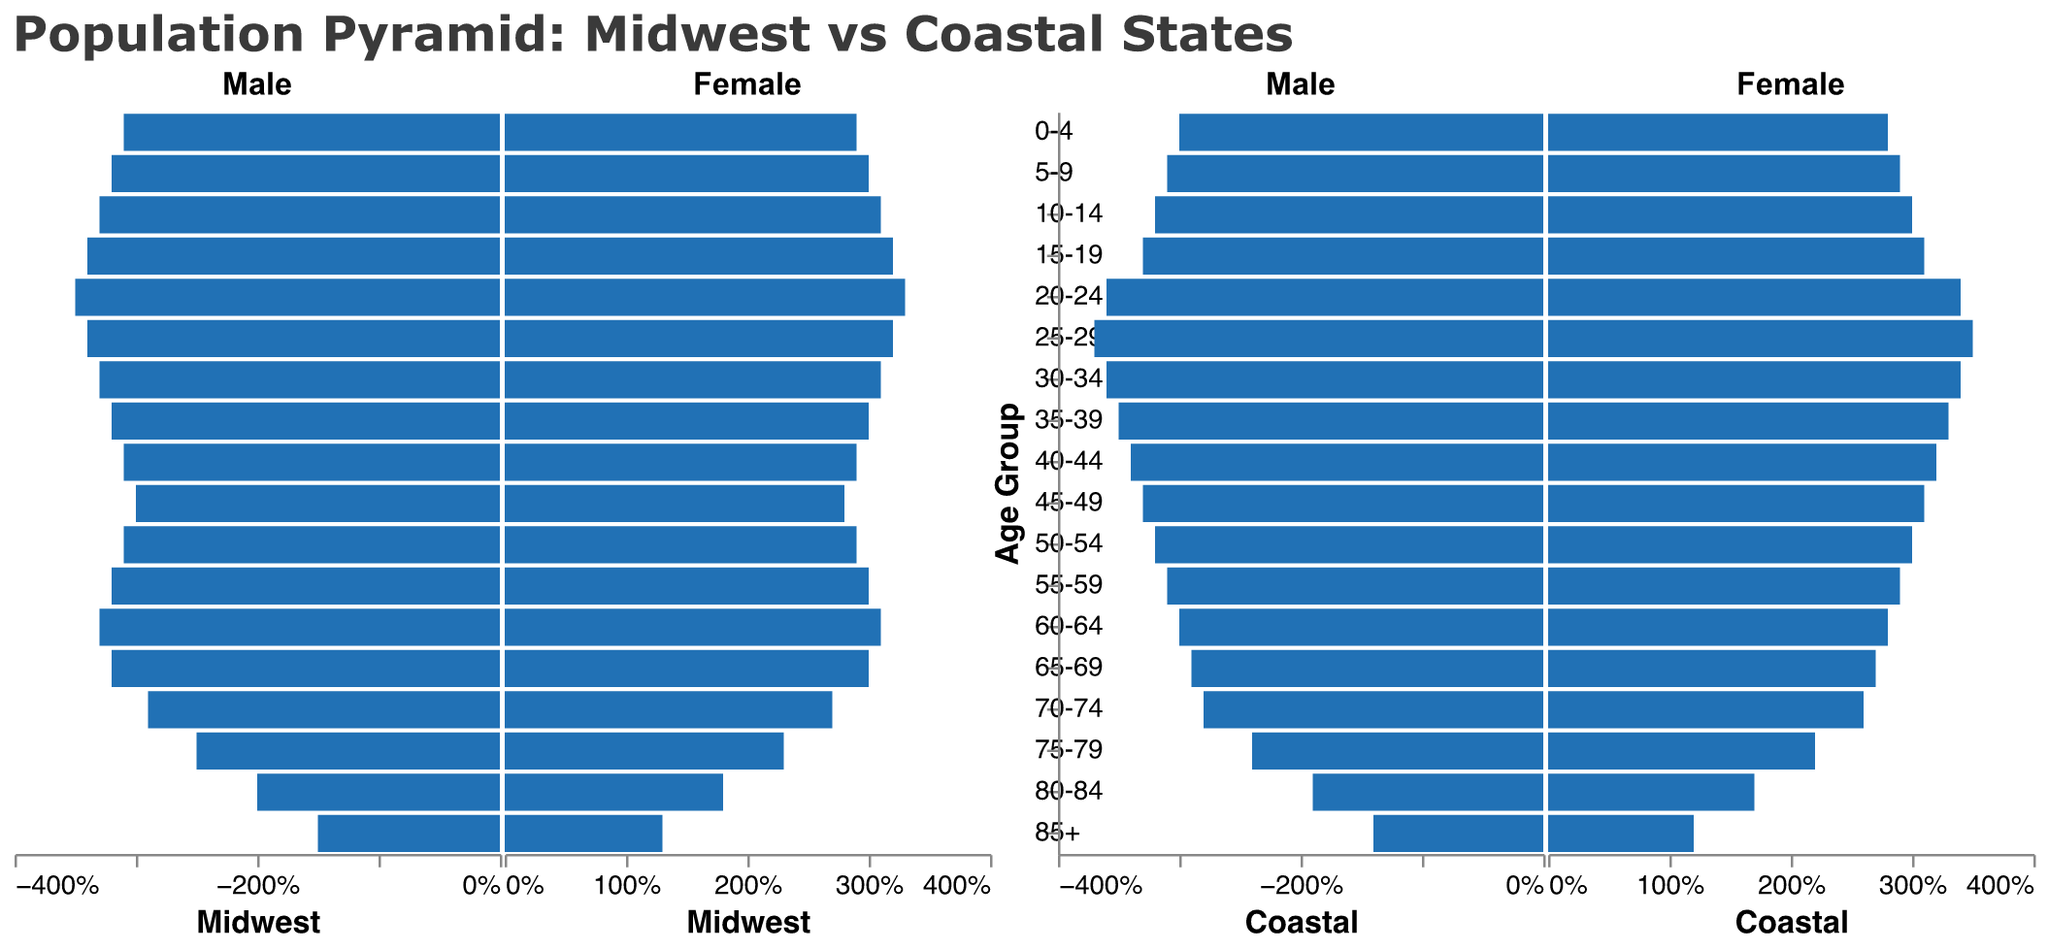What is the title of the figure? The title can be found at the top of the figure. It reads "Population Pyramid: Midwest vs Coastal States".
Answer: Population Pyramid: Midwest vs Coastal States What is the age group with the highest percentage of males in the Midwest? By referring to the bars in the "Male" section for Midwest, the age group "20-24" has the highest percentage, with a value of 3.5%.
Answer: 20-24 What is the percentage difference of females aged 25-29 between the Midwest and Coastal regions? In the "Female" section, find the values for age group "25-29". For the Midwest, it is 3.2%, and for the Coastal, it is 3.5%. The difference is 3.5% - 3.2% = 0.3%.
Answer: 0.3% Which region has a higher percentage of females aged 65-69? By comparing the "Female" section for the age group "65-69", Midwest has 3.0% while Coastal has 2.7%.
Answer: Midwest In the age group 70-74, which gender has a higher percentage in the Coastal region? In the Coastal region, compare the percentages of males and females in the age group "70-74". Males are at 2.8%, while females are at 2.6%.
Answer: Males What is the sum of the percentages of all males in the Midwest for the age groups 0-4 and 5-9? For the Midwest Male, the age groups "0-4" and "5-9" have the percentages 3.1% and 3.2%, respectively. The sum is 3.1% + 3.2% = 6.3%.
Answer: 6.3% Does any age group have an equal percentage for both males and females in the Midwest? By comparing each age group for Midwest Male and Female percentages from the data, none of the age groups have equal percentages for both genders.
Answer: No Which age group shows the largest difference in percentage between Coastal and Midwest males? Calculate the differences for each age group, e.g., for 20-24, it is abs(3.6% - 3.5%) = 0.1%. The largest difference is for the age group 25-29, with abs(3.7% - 3.4%) = 0.3%.
Answer: 25-29 What is the overall trend in the distribution of the elderly population (age 65+) for both regions? By observing the percentages of age groups 65+ for both regions, there's a gradual decrease in population percentages with increasing age, indicating an aging population but fewer people in older age groups.
Answer: Gradual decrease with increasing age 